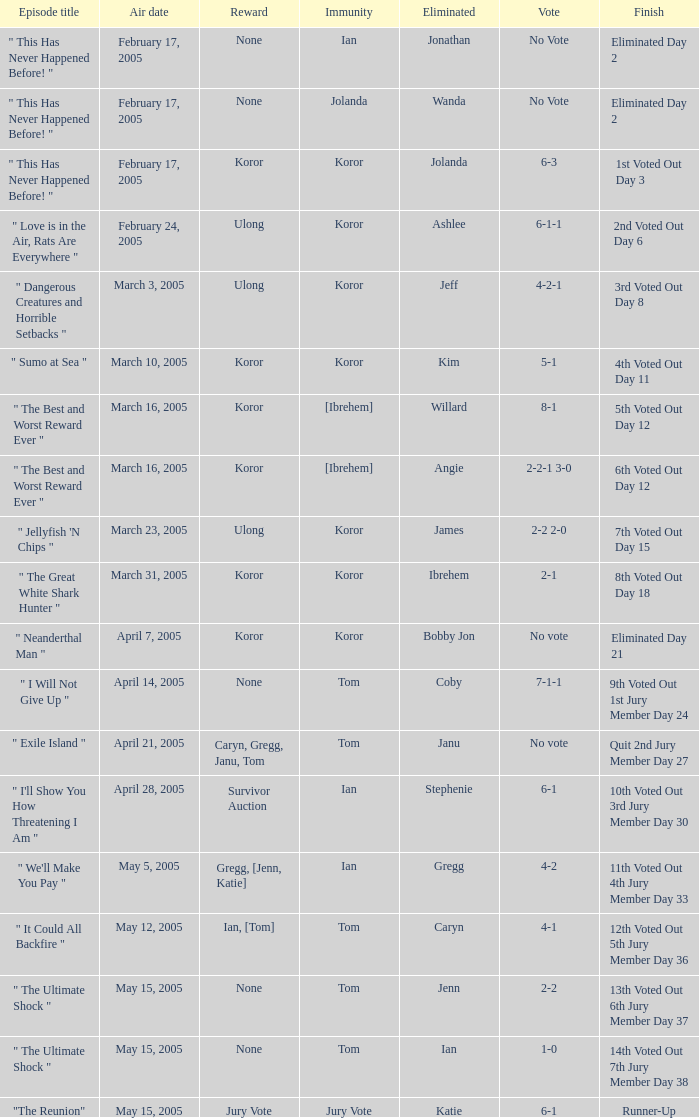During the episode of wanda's elimination, what was the number of people who had immunity? 1.0. 